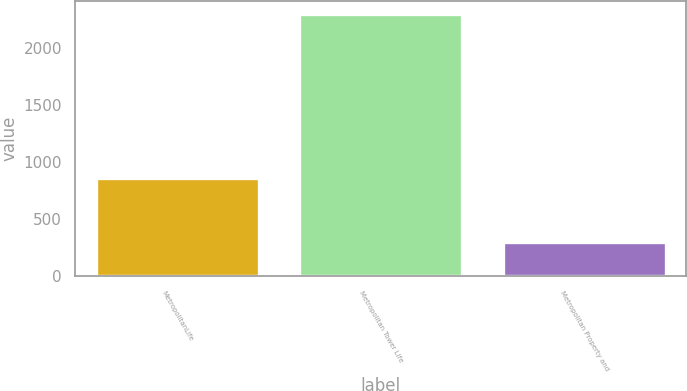Convert chart. <chart><loc_0><loc_0><loc_500><loc_500><bar_chart><fcel>MetropolitanLife<fcel>Metropolitan Tower Life<fcel>Metropolitan Property and<nl><fcel>863<fcel>2300<fcel>300<nl></chart> 